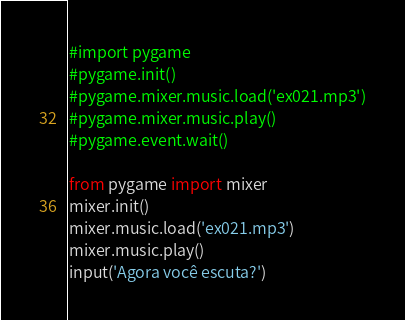<code> <loc_0><loc_0><loc_500><loc_500><_Python_>#import pygame
#pygame.init()
#pygame.mixer.music.load('ex021.mp3')
#pygame.mixer.music.play()
#pygame.event.wait()

from pygame import mixer
mixer.init()
mixer.music.load('ex021.mp3')
mixer.music.play()
input('Agora você escuta?')</code> 